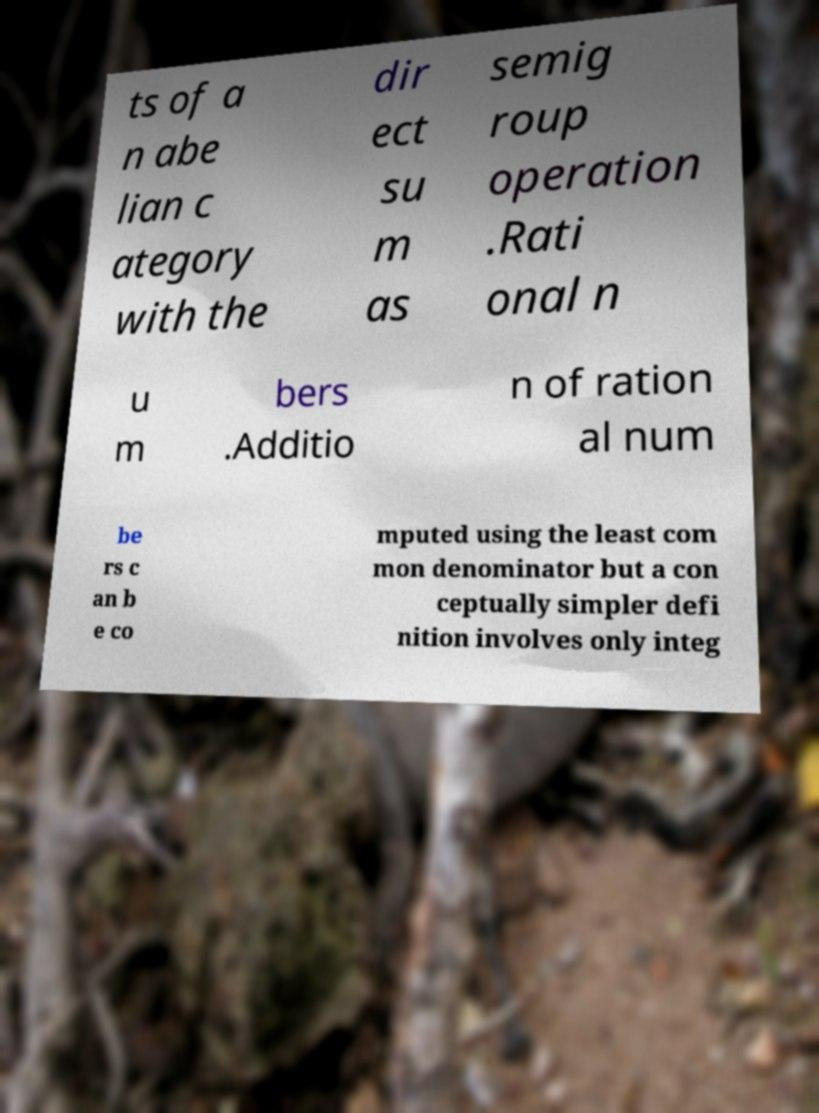I need the written content from this picture converted into text. Can you do that? ts of a n abe lian c ategory with the dir ect su m as semig roup operation .Rati onal n u m bers .Additio n of ration al num be rs c an b e co mputed using the least com mon denominator but a con ceptually simpler defi nition involves only integ 